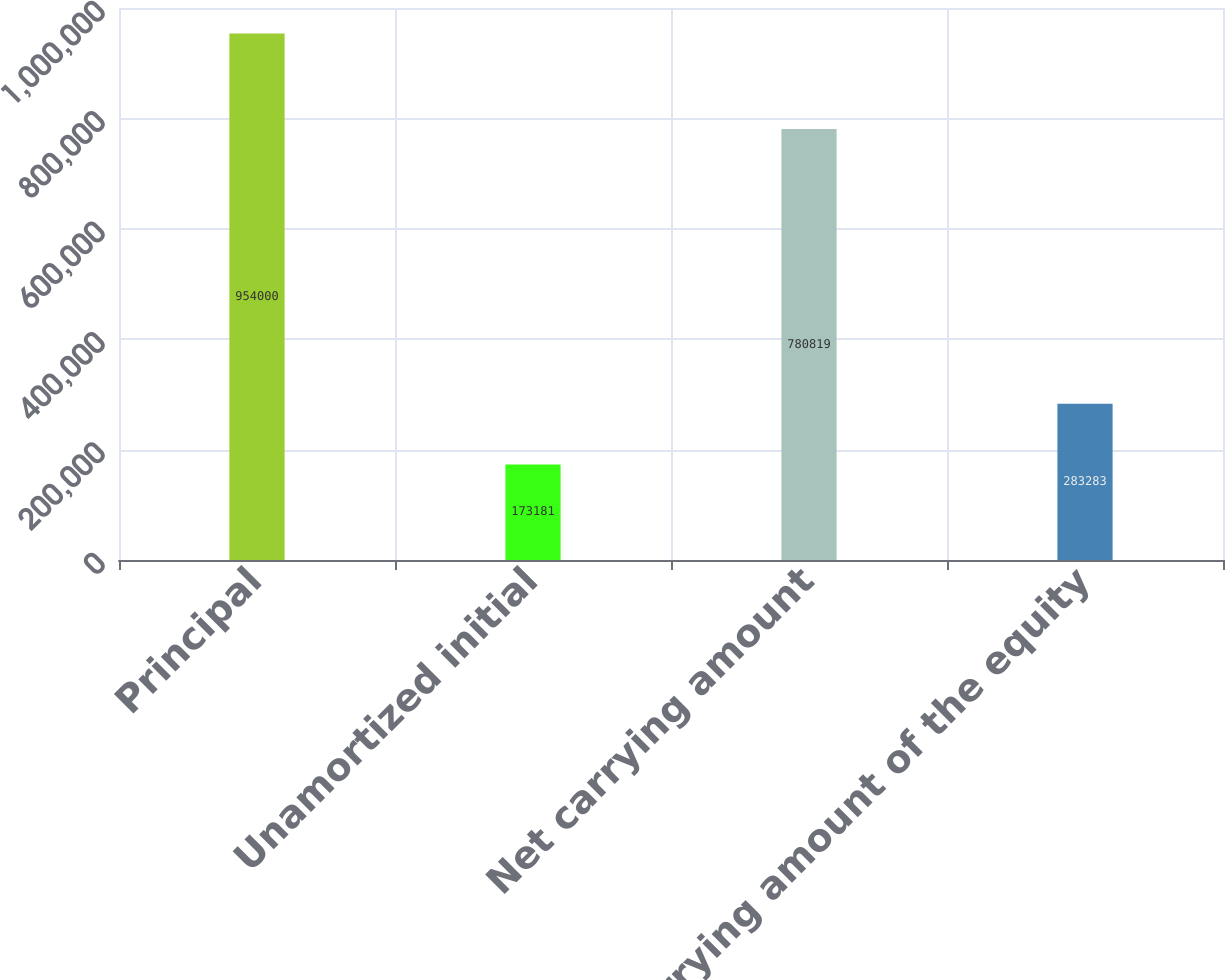Convert chart. <chart><loc_0><loc_0><loc_500><loc_500><bar_chart><fcel>Principal<fcel>Unamortized initial<fcel>Net carrying amount<fcel>Carrying amount of the equity<nl><fcel>954000<fcel>173181<fcel>780819<fcel>283283<nl></chart> 